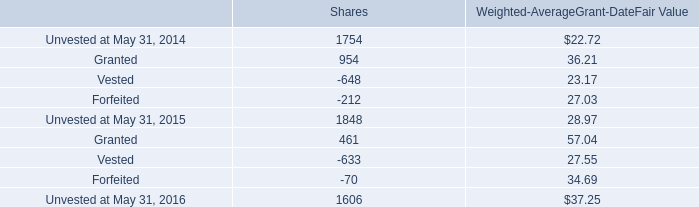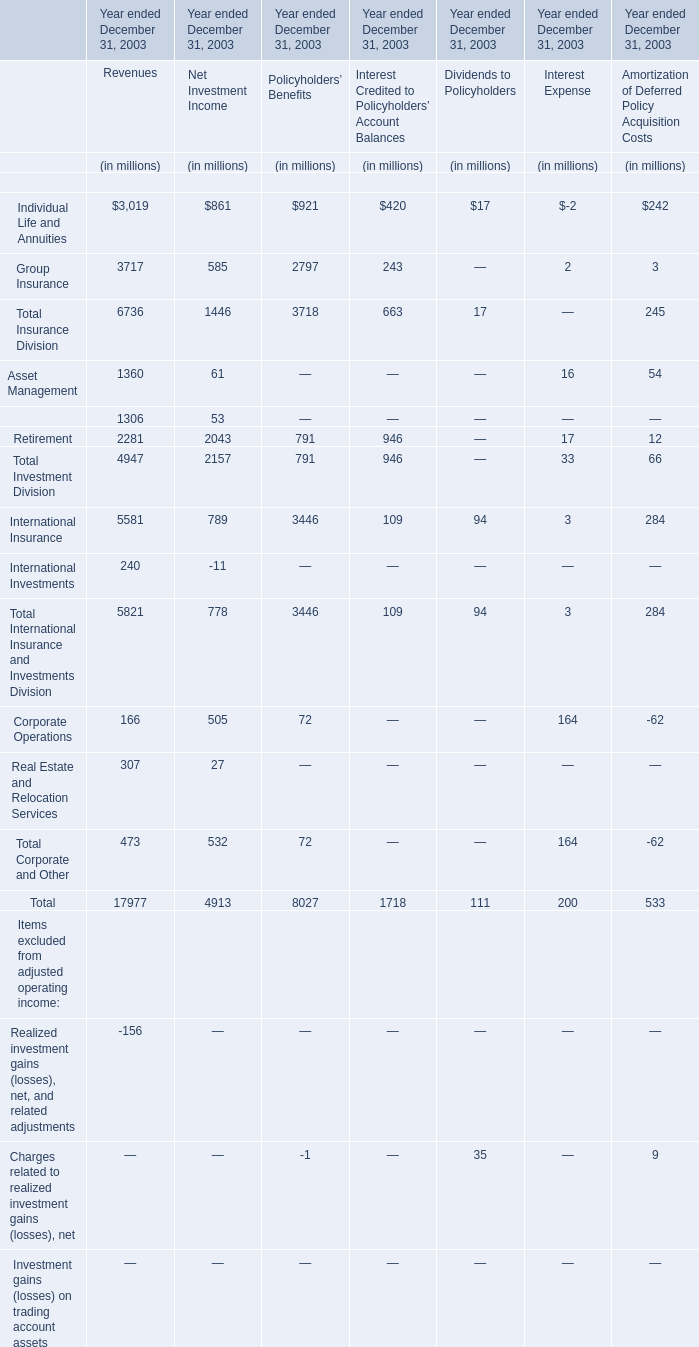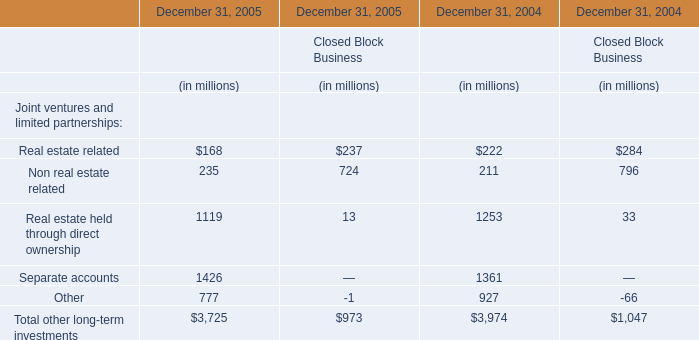What was the sum of Individual Life and Annuities without those Individual Life and Annuities smaller than 900 in 2003? (in million) 
Computations: ((3019 + 861) + 921)
Answer: 4801.0. 